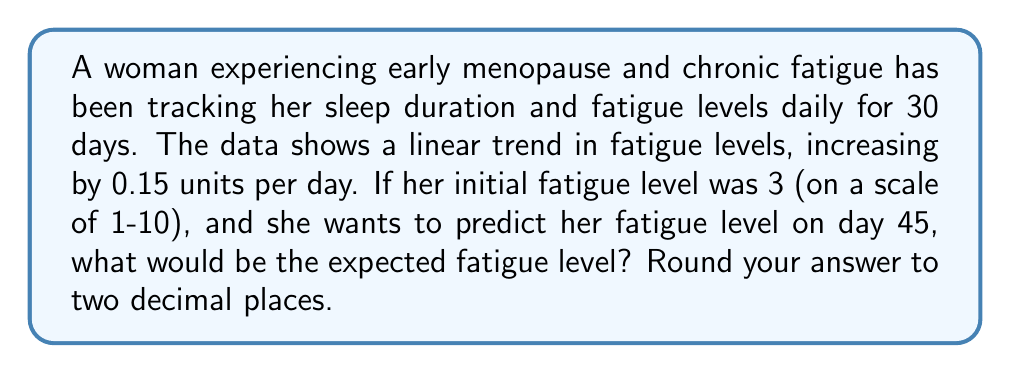Can you solve this math problem? To solve this problem, we'll use a simple linear time series model:

1) Let $y_t$ be the fatigue level on day $t$.
2) The linear trend is given by the equation:
   $$y_t = y_0 + bt$$
   where $y_0$ is the initial fatigue level and $b$ is the daily increase.

3) We're given:
   $y_0 = 3$ (initial fatigue level)
   $b = 0.15$ (daily increase)
   $t = 45$ (day we're predicting)

4) Substituting these values into our equation:
   $$y_{45} = 3 + 0.15 \cdot 45$$

5) Calculating:
   $$y_{45} = 3 + 6.75 = 9.75$$

6) Rounding to two decimal places:
   $$y_{45} \approx 9.75$$

This result suggests that if the linear trend continues, the fatigue level would be expected to reach 9.75 on day 45, which is quite high on a 1-10 scale.
Answer: 9.75 